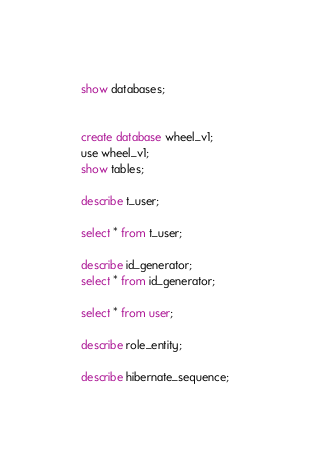<code> <loc_0><loc_0><loc_500><loc_500><_SQL_>show databases;


create database wheel_v1;
use wheel_v1;
show tables;

describe t_user;

select * from t_user;

describe id_generator;
select * from id_generator;

select * from user;

describe role_entity;

describe hibernate_sequence;</code> 